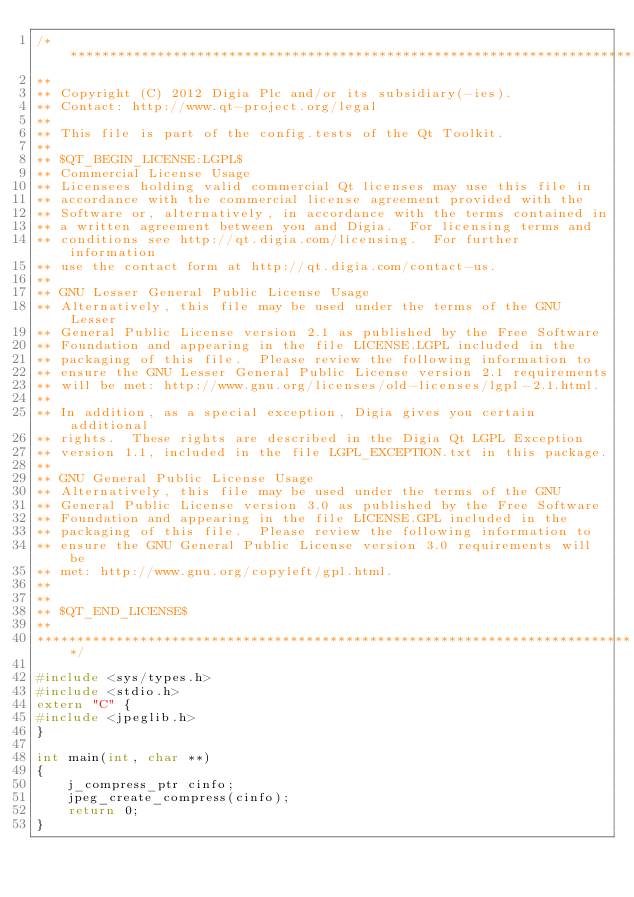Convert code to text. <code><loc_0><loc_0><loc_500><loc_500><_C++_>/****************************************************************************
**
** Copyright (C) 2012 Digia Plc and/or its subsidiary(-ies).
** Contact: http://www.qt-project.org/legal
**
** This file is part of the config.tests of the Qt Toolkit.
**
** $QT_BEGIN_LICENSE:LGPL$
** Commercial License Usage
** Licensees holding valid commercial Qt licenses may use this file in
** accordance with the commercial license agreement provided with the
** Software or, alternatively, in accordance with the terms contained in
** a written agreement between you and Digia.  For licensing terms and
** conditions see http://qt.digia.com/licensing.  For further information
** use the contact form at http://qt.digia.com/contact-us.
**
** GNU Lesser General Public License Usage
** Alternatively, this file may be used under the terms of the GNU Lesser
** General Public License version 2.1 as published by the Free Software
** Foundation and appearing in the file LICENSE.LGPL included in the
** packaging of this file.  Please review the following information to
** ensure the GNU Lesser General Public License version 2.1 requirements
** will be met: http://www.gnu.org/licenses/old-licenses/lgpl-2.1.html.
**
** In addition, as a special exception, Digia gives you certain additional
** rights.  These rights are described in the Digia Qt LGPL Exception
** version 1.1, included in the file LGPL_EXCEPTION.txt in this package.
**
** GNU General Public License Usage
** Alternatively, this file may be used under the terms of the GNU
** General Public License version 3.0 as published by the Free Software
** Foundation and appearing in the file LICENSE.GPL included in the
** packaging of this file.  Please review the following information to
** ensure the GNU General Public License version 3.0 requirements will be
** met: http://www.gnu.org/copyleft/gpl.html.
**
**
** $QT_END_LICENSE$
**
****************************************************************************/

#include <sys/types.h>
#include <stdio.h>
extern "C" {
#include <jpeglib.h>
}

int main(int, char **)
{
    j_compress_ptr cinfo;
    jpeg_create_compress(cinfo);
    return 0;
}
</code> 